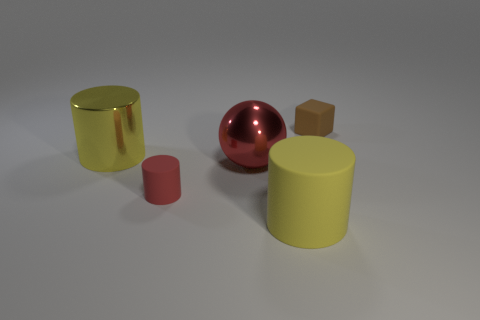Are there more large red things behind the brown matte block than small red metal cylinders?
Make the answer very short. No. How many large yellow things are right of the tiny red thing?
Offer a very short reply. 1. There is a big metallic thing that is the same color as the tiny cylinder; what shape is it?
Offer a very short reply. Sphere. There is a tiny object that is right of the small thing in front of the brown rubber object; are there any brown matte objects on the left side of it?
Provide a succinct answer. No. Do the red rubber object and the yellow rubber thing have the same size?
Ensure brevity in your answer.  No. Are there the same number of rubber cylinders that are behind the metallic ball and small red cylinders right of the big yellow rubber cylinder?
Provide a succinct answer. Yes. What shape is the yellow object that is on the right side of the yellow metal cylinder?
Your answer should be compact. Cylinder. The yellow thing that is the same size as the shiny cylinder is what shape?
Make the answer very short. Cylinder. What color is the tiny rubber object on the left side of the tiny rubber thing behind the tiny object in front of the tiny matte block?
Ensure brevity in your answer.  Red. Is the brown object the same shape as the red rubber object?
Ensure brevity in your answer.  No. 